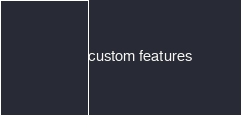Convert code to text. <code><loc_0><loc_0><loc_500><loc_500><_SML_>custom features</code> 